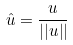Convert formula to latex. <formula><loc_0><loc_0><loc_500><loc_500>\hat { u } = \frac { u } { | | u | | }</formula> 